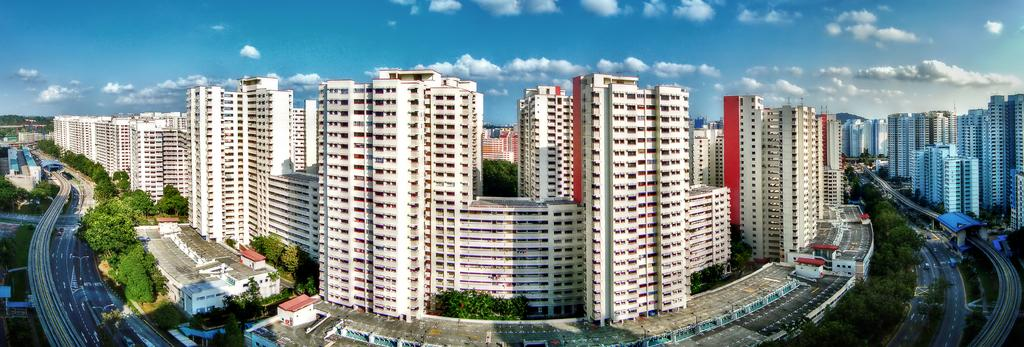What type of structures can be seen in the image? There are buildings in the image. What other natural elements are present in the image? There are trees in the image. What mode of transportation can be seen on the road in the image? There are vehicles on the road in the image. What is visible in the background of the image? The sky is visible in the image. What can be observed in the sky? Clouds are present in the sky. What type of wrist accessory is visible on the trees in the image? There is no wrist accessory present on the trees in the image. How many quartz crystals can be seen on the buildings in the image? There are no quartz crystals present on the buildings in the image. 